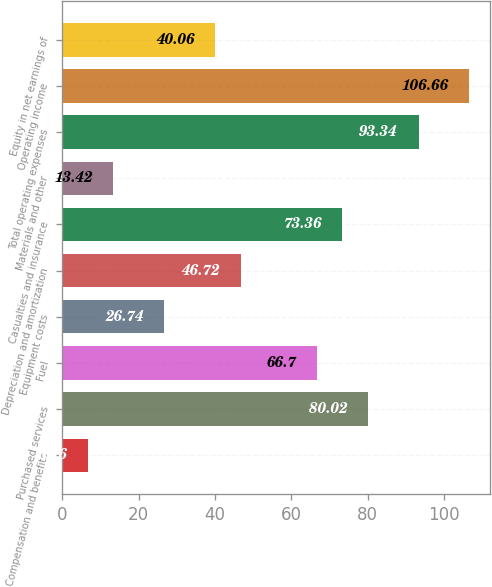<chart> <loc_0><loc_0><loc_500><loc_500><bar_chart><fcel>Compensation and benefits<fcel>Purchased services<fcel>Fuel<fcel>Equipment costs<fcel>Depreciation and amortization<fcel>Casualties and insurance<fcel>Materials and other<fcel>Total operating expenses<fcel>Operating income<fcel>Equity in net earnings of<nl><fcel>6.76<fcel>80.02<fcel>66.7<fcel>26.74<fcel>46.72<fcel>73.36<fcel>13.42<fcel>93.34<fcel>106.66<fcel>40.06<nl></chart> 